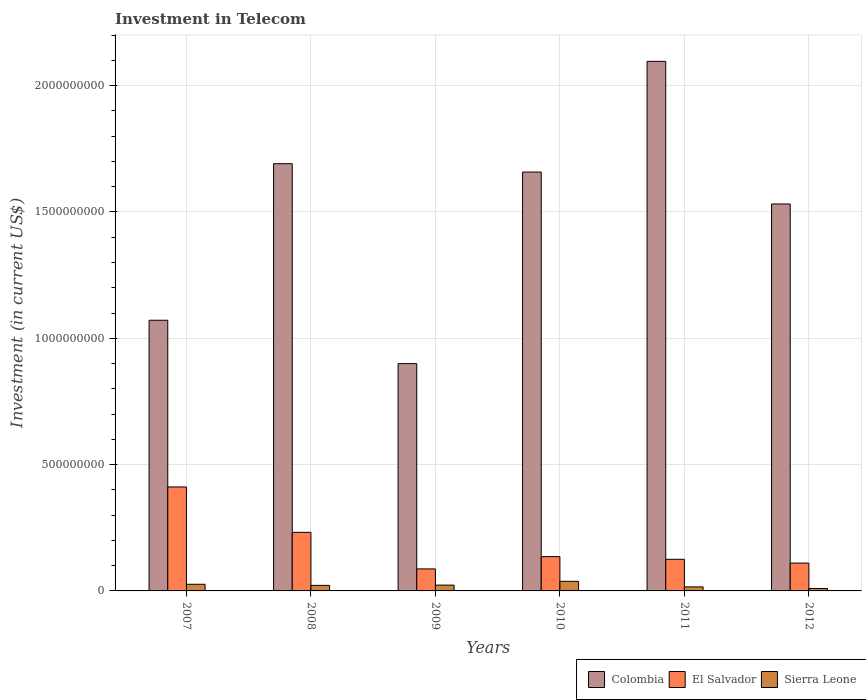How many different coloured bars are there?
Make the answer very short. 3. How many groups of bars are there?
Keep it short and to the point. 6. Are the number of bars per tick equal to the number of legend labels?
Provide a short and direct response. Yes. Are the number of bars on each tick of the X-axis equal?
Your response must be concise. Yes. How many bars are there on the 6th tick from the left?
Make the answer very short. 3. How many bars are there on the 3rd tick from the right?
Ensure brevity in your answer.  3. What is the amount invested in telecom in El Salvador in 2009?
Offer a very short reply. 8.71e+07. Across all years, what is the maximum amount invested in telecom in Sierra Leone?
Your response must be concise. 3.80e+07. Across all years, what is the minimum amount invested in telecom in El Salvador?
Offer a very short reply. 8.71e+07. In which year was the amount invested in telecom in Colombia minimum?
Give a very brief answer. 2009. What is the total amount invested in telecom in Colombia in the graph?
Provide a succinct answer. 8.95e+09. What is the difference between the amount invested in telecom in Sierra Leone in 2007 and that in 2010?
Give a very brief answer. -1.17e+07. What is the difference between the amount invested in telecom in El Salvador in 2009 and the amount invested in telecom in Colombia in 2012?
Give a very brief answer. -1.44e+09. What is the average amount invested in telecom in Colombia per year?
Ensure brevity in your answer.  1.49e+09. In the year 2007, what is the difference between the amount invested in telecom in Colombia and amount invested in telecom in Sierra Leone?
Your response must be concise. 1.05e+09. In how many years, is the amount invested in telecom in El Salvador greater than 200000000 US$?
Your answer should be compact. 2. What is the ratio of the amount invested in telecom in Sierra Leone in 2011 to that in 2012?
Keep it short and to the point. 1.64. Is the difference between the amount invested in telecom in Colombia in 2008 and 2012 greater than the difference between the amount invested in telecom in Sierra Leone in 2008 and 2012?
Your response must be concise. Yes. What is the difference between the highest and the second highest amount invested in telecom in Sierra Leone?
Your answer should be very brief. 1.17e+07. What is the difference between the highest and the lowest amount invested in telecom in Sierra Leone?
Your response must be concise. 2.83e+07. In how many years, is the amount invested in telecom in Sierra Leone greater than the average amount invested in telecom in Sierra Leone taken over all years?
Make the answer very short. 3. Is it the case that in every year, the sum of the amount invested in telecom in El Salvador and amount invested in telecom in Colombia is greater than the amount invested in telecom in Sierra Leone?
Ensure brevity in your answer.  Yes. Are all the bars in the graph horizontal?
Offer a very short reply. No. How many years are there in the graph?
Provide a succinct answer. 6. Are the values on the major ticks of Y-axis written in scientific E-notation?
Offer a very short reply. No. Where does the legend appear in the graph?
Keep it short and to the point. Bottom right. How many legend labels are there?
Provide a short and direct response. 3. What is the title of the graph?
Offer a very short reply. Investment in Telecom. What is the label or title of the Y-axis?
Provide a short and direct response. Investment (in current US$). What is the Investment (in current US$) of Colombia in 2007?
Provide a short and direct response. 1.07e+09. What is the Investment (in current US$) of El Salvador in 2007?
Give a very brief answer. 4.11e+08. What is the Investment (in current US$) in Sierra Leone in 2007?
Keep it short and to the point. 2.63e+07. What is the Investment (in current US$) in Colombia in 2008?
Provide a short and direct response. 1.69e+09. What is the Investment (in current US$) of El Salvador in 2008?
Your answer should be compact. 2.32e+08. What is the Investment (in current US$) in Sierra Leone in 2008?
Offer a terse response. 2.19e+07. What is the Investment (in current US$) in Colombia in 2009?
Provide a short and direct response. 9.00e+08. What is the Investment (in current US$) in El Salvador in 2009?
Your answer should be very brief. 8.71e+07. What is the Investment (in current US$) in Sierra Leone in 2009?
Your response must be concise. 2.30e+07. What is the Investment (in current US$) of Colombia in 2010?
Ensure brevity in your answer.  1.66e+09. What is the Investment (in current US$) in El Salvador in 2010?
Ensure brevity in your answer.  1.36e+08. What is the Investment (in current US$) in Sierra Leone in 2010?
Provide a short and direct response. 3.80e+07. What is the Investment (in current US$) of Colombia in 2011?
Ensure brevity in your answer.  2.10e+09. What is the Investment (in current US$) in El Salvador in 2011?
Your answer should be very brief. 1.25e+08. What is the Investment (in current US$) in Sierra Leone in 2011?
Offer a terse response. 1.59e+07. What is the Investment (in current US$) of Colombia in 2012?
Provide a short and direct response. 1.53e+09. What is the Investment (in current US$) in El Salvador in 2012?
Provide a succinct answer. 1.10e+08. What is the Investment (in current US$) in Sierra Leone in 2012?
Make the answer very short. 9.70e+06. Across all years, what is the maximum Investment (in current US$) of Colombia?
Ensure brevity in your answer.  2.10e+09. Across all years, what is the maximum Investment (in current US$) in El Salvador?
Your answer should be very brief. 4.11e+08. Across all years, what is the maximum Investment (in current US$) of Sierra Leone?
Provide a succinct answer. 3.80e+07. Across all years, what is the minimum Investment (in current US$) in Colombia?
Give a very brief answer. 9.00e+08. Across all years, what is the minimum Investment (in current US$) of El Salvador?
Offer a terse response. 8.71e+07. Across all years, what is the minimum Investment (in current US$) of Sierra Leone?
Offer a terse response. 9.70e+06. What is the total Investment (in current US$) of Colombia in the graph?
Provide a short and direct response. 8.95e+09. What is the total Investment (in current US$) of El Salvador in the graph?
Keep it short and to the point. 1.10e+09. What is the total Investment (in current US$) of Sierra Leone in the graph?
Your answer should be compact. 1.35e+08. What is the difference between the Investment (in current US$) in Colombia in 2007 and that in 2008?
Offer a very short reply. -6.20e+08. What is the difference between the Investment (in current US$) of El Salvador in 2007 and that in 2008?
Give a very brief answer. 1.80e+08. What is the difference between the Investment (in current US$) of Sierra Leone in 2007 and that in 2008?
Provide a succinct answer. 4.40e+06. What is the difference between the Investment (in current US$) in Colombia in 2007 and that in 2009?
Your answer should be compact. 1.72e+08. What is the difference between the Investment (in current US$) in El Salvador in 2007 and that in 2009?
Offer a very short reply. 3.24e+08. What is the difference between the Investment (in current US$) in Sierra Leone in 2007 and that in 2009?
Offer a very short reply. 3.30e+06. What is the difference between the Investment (in current US$) in Colombia in 2007 and that in 2010?
Ensure brevity in your answer.  -5.86e+08. What is the difference between the Investment (in current US$) of El Salvador in 2007 and that in 2010?
Ensure brevity in your answer.  2.76e+08. What is the difference between the Investment (in current US$) of Sierra Leone in 2007 and that in 2010?
Offer a terse response. -1.17e+07. What is the difference between the Investment (in current US$) of Colombia in 2007 and that in 2011?
Keep it short and to the point. -1.02e+09. What is the difference between the Investment (in current US$) in El Salvador in 2007 and that in 2011?
Your answer should be very brief. 2.86e+08. What is the difference between the Investment (in current US$) of Sierra Leone in 2007 and that in 2011?
Ensure brevity in your answer.  1.04e+07. What is the difference between the Investment (in current US$) of Colombia in 2007 and that in 2012?
Give a very brief answer. -4.60e+08. What is the difference between the Investment (in current US$) in El Salvador in 2007 and that in 2012?
Provide a short and direct response. 3.01e+08. What is the difference between the Investment (in current US$) in Sierra Leone in 2007 and that in 2012?
Provide a succinct answer. 1.66e+07. What is the difference between the Investment (in current US$) in Colombia in 2008 and that in 2009?
Offer a terse response. 7.91e+08. What is the difference between the Investment (in current US$) of El Salvador in 2008 and that in 2009?
Give a very brief answer. 1.45e+08. What is the difference between the Investment (in current US$) in Sierra Leone in 2008 and that in 2009?
Your answer should be compact. -1.10e+06. What is the difference between the Investment (in current US$) of Colombia in 2008 and that in 2010?
Your answer should be very brief. 3.31e+07. What is the difference between the Investment (in current US$) in El Salvador in 2008 and that in 2010?
Keep it short and to the point. 9.61e+07. What is the difference between the Investment (in current US$) of Sierra Leone in 2008 and that in 2010?
Ensure brevity in your answer.  -1.61e+07. What is the difference between the Investment (in current US$) in Colombia in 2008 and that in 2011?
Offer a terse response. -4.05e+08. What is the difference between the Investment (in current US$) of El Salvador in 2008 and that in 2011?
Offer a terse response. 1.07e+08. What is the difference between the Investment (in current US$) in Sierra Leone in 2008 and that in 2011?
Your response must be concise. 6.00e+06. What is the difference between the Investment (in current US$) in Colombia in 2008 and that in 2012?
Provide a short and direct response. 1.59e+08. What is the difference between the Investment (in current US$) in El Salvador in 2008 and that in 2012?
Your answer should be very brief. 1.22e+08. What is the difference between the Investment (in current US$) in Sierra Leone in 2008 and that in 2012?
Your response must be concise. 1.22e+07. What is the difference between the Investment (in current US$) in Colombia in 2009 and that in 2010?
Offer a terse response. -7.58e+08. What is the difference between the Investment (in current US$) in El Salvador in 2009 and that in 2010?
Offer a very short reply. -4.86e+07. What is the difference between the Investment (in current US$) in Sierra Leone in 2009 and that in 2010?
Your answer should be compact. -1.50e+07. What is the difference between the Investment (in current US$) in Colombia in 2009 and that in 2011?
Give a very brief answer. -1.20e+09. What is the difference between the Investment (in current US$) in El Salvador in 2009 and that in 2011?
Provide a short and direct response. -3.81e+07. What is the difference between the Investment (in current US$) of Sierra Leone in 2009 and that in 2011?
Your answer should be compact. 7.10e+06. What is the difference between the Investment (in current US$) of Colombia in 2009 and that in 2012?
Provide a short and direct response. -6.32e+08. What is the difference between the Investment (in current US$) of El Salvador in 2009 and that in 2012?
Your answer should be very brief. -2.31e+07. What is the difference between the Investment (in current US$) in Sierra Leone in 2009 and that in 2012?
Make the answer very short. 1.33e+07. What is the difference between the Investment (in current US$) in Colombia in 2010 and that in 2011?
Offer a terse response. -4.38e+08. What is the difference between the Investment (in current US$) in El Salvador in 2010 and that in 2011?
Your answer should be very brief. 1.05e+07. What is the difference between the Investment (in current US$) of Sierra Leone in 2010 and that in 2011?
Make the answer very short. 2.21e+07. What is the difference between the Investment (in current US$) of Colombia in 2010 and that in 2012?
Offer a terse response. 1.26e+08. What is the difference between the Investment (in current US$) in El Salvador in 2010 and that in 2012?
Offer a very short reply. 2.55e+07. What is the difference between the Investment (in current US$) of Sierra Leone in 2010 and that in 2012?
Make the answer very short. 2.83e+07. What is the difference between the Investment (in current US$) of Colombia in 2011 and that in 2012?
Your response must be concise. 5.64e+08. What is the difference between the Investment (in current US$) in El Salvador in 2011 and that in 2012?
Your response must be concise. 1.50e+07. What is the difference between the Investment (in current US$) in Sierra Leone in 2011 and that in 2012?
Provide a short and direct response. 6.20e+06. What is the difference between the Investment (in current US$) of Colombia in 2007 and the Investment (in current US$) of El Salvador in 2008?
Your answer should be very brief. 8.40e+08. What is the difference between the Investment (in current US$) of Colombia in 2007 and the Investment (in current US$) of Sierra Leone in 2008?
Make the answer very short. 1.05e+09. What is the difference between the Investment (in current US$) in El Salvador in 2007 and the Investment (in current US$) in Sierra Leone in 2008?
Offer a terse response. 3.90e+08. What is the difference between the Investment (in current US$) in Colombia in 2007 and the Investment (in current US$) in El Salvador in 2009?
Give a very brief answer. 9.84e+08. What is the difference between the Investment (in current US$) in Colombia in 2007 and the Investment (in current US$) in Sierra Leone in 2009?
Offer a terse response. 1.05e+09. What is the difference between the Investment (in current US$) of El Salvador in 2007 and the Investment (in current US$) of Sierra Leone in 2009?
Offer a very short reply. 3.88e+08. What is the difference between the Investment (in current US$) of Colombia in 2007 and the Investment (in current US$) of El Salvador in 2010?
Provide a succinct answer. 9.36e+08. What is the difference between the Investment (in current US$) in Colombia in 2007 and the Investment (in current US$) in Sierra Leone in 2010?
Your response must be concise. 1.03e+09. What is the difference between the Investment (in current US$) in El Salvador in 2007 and the Investment (in current US$) in Sierra Leone in 2010?
Offer a very short reply. 3.73e+08. What is the difference between the Investment (in current US$) in Colombia in 2007 and the Investment (in current US$) in El Salvador in 2011?
Provide a short and direct response. 9.46e+08. What is the difference between the Investment (in current US$) in Colombia in 2007 and the Investment (in current US$) in Sierra Leone in 2011?
Ensure brevity in your answer.  1.06e+09. What is the difference between the Investment (in current US$) in El Salvador in 2007 and the Investment (in current US$) in Sierra Leone in 2011?
Give a very brief answer. 3.96e+08. What is the difference between the Investment (in current US$) in Colombia in 2007 and the Investment (in current US$) in El Salvador in 2012?
Ensure brevity in your answer.  9.61e+08. What is the difference between the Investment (in current US$) in Colombia in 2007 and the Investment (in current US$) in Sierra Leone in 2012?
Offer a very short reply. 1.06e+09. What is the difference between the Investment (in current US$) in El Salvador in 2007 and the Investment (in current US$) in Sierra Leone in 2012?
Your answer should be compact. 4.02e+08. What is the difference between the Investment (in current US$) of Colombia in 2008 and the Investment (in current US$) of El Salvador in 2009?
Make the answer very short. 1.60e+09. What is the difference between the Investment (in current US$) of Colombia in 2008 and the Investment (in current US$) of Sierra Leone in 2009?
Keep it short and to the point. 1.67e+09. What is the difference between the Investment (in current US$) in El Salvador in 2008 and the Investment (in current US$) in Sierra Leone in 2009?
Provide a succinct answer. 2.09e+08. What is the difference between the Investment (in current US$) of Colombia in 2008 and the Investment (in current US$) of El Salvador in 2010?
Offer a terse response. 1.56e+09. What is the difference between the Investment (in current US$) of Colombia in 2008 and the Investment (in current US$) of Sierra Leone in 2010?
Make the answer very short. 1.65e+09. What is the difference between the Investment (in current US$) of El Salvador in 2008 and the Investment (in current US$) of Sierra Leone in 2010?
Your answer should be very brief. 1.94e+08. What is the difference between the Investment (in current US$) of Colombia in 2008 and the Investment (in current US$) of El Salvador in 2011?
Offer a very short reply. 1.57e+09. What is the difference between the Investment (in current US$) of Colombia in 2008 and the Investment (in current US$) of Sierra Leone in 2011?
Provide a succinct answer. 1.68e+09. What is the difference between the Investment (in current US$) of El Salvador in 2008 and the Investment (in current US$) of Sierra Leone in 2011?
Your response must be concise. 2.16e+08. What is the difference between the Investment (in current US$) of Colombia in 2008 and the Investment (in current US$) of El Salvador in 2012?
Provide a short and direct response. 1.58e+09. What is the difference between the Investment (in current US$) in Colombia in 2008 and the Investment (in current US$) in Sierra Leone in 2012?
Your answer should be very brief. 1.68e+09. What is the difference between the Investment (in current US$) in El Salvador in 2008 and the Investment (in current US$) in Sierra Leone in 2012?
Offer a very short reply. 2.22e+08. What is the difference between the Investment (in current US$) in Colombia in 2009 and the Investment (in current US$) in El Salvador in 2010?
Ensure brevity in your answer.  7.64e+08. What is the difference between the Investment (in current US$) in Colombia in 2009 and the Investment (in current US$) in Sierra Leone in 2010?
Offer a very short reply. 8.62e+08. What is the difference between the Investment (in current US$) in El Salvador in 2009 and the Investment (in current US$) in Sierra Leone in 2010?
Offer a terse response. 4.91e+07. What is the difference between the Investment (in current US$) in Colombia in 2009 and the Investment (in current US$) in El Salvador in 2011?
Provide a short and direct response. 7.74e+08. What is the difference between the Investment (in current US$) in Colombia in 2009 and the Investment (in current US$) in Sierra Leone in 2011?
Give a very brief answer. 8.84e+08. What is the difference between the Investment (in current US$) of El Salvador in 2009 and the Investment (in current US$) of Sierra Leone in 2011?
Your response must be concise. 7.12e+07. What is the difference between the Investment (in current US$) in Colombia in 2009 and the Investment (in current US$) in El Salvador in 2012?
Your response must be concise. 7.90e+08. What is the difference between the Investment (in current US$) of Colombia in 2009 and the Investment (in current US$) of Sierra Leone in 2012?
Provide a short and direct response. 8.90e+08. What is the difference between the Investment (in current US$) of El Salvador in 2009 and the Investment (in current US$) of Sierra Leone in 2012?
Offer a terse response. 7.74e+07. What is the difference between the Investment (in current US$) in Colombia in 2010 and the Investment (in current US$) in El Salvador in 2011?
Your response must be concise. 1.53e+09. What is the difference between the Investment (in current US$) in Colombia in 2010 and the Investment (in current US$) in Sierra Leone in 2011?
Your response must be concise. 1.64e+09. What is the difference between the Investment (in current US$) in El Salvador in 2010 and the Investment (in current US$) in Sierra Leone in 2011?
Give a very brief answer. 1.20e+08. What is the difference between the Investment (in current US$) of Colombia in 2010 and the Investment (in current US$) of El Salvador in 2012?
Offer a very short reply. 1.55e+09. What is the difference between the Investment (in current US$) in Colombia in 2010 and the Investment (in current US$) in Sierra Leone in 2012?
Provide a succinct answer. 1.65e+09. What is the difference between the Investment (in current US$) of El Salvador in 2010 and the Investment (in current US$) of Sierra Leone in 2012?
Make the answer very short. 1.26e+08. What is the difference between the Investment (in current US$) of Colombia in 2011 and the Investment (in current US$) of El Salvador in 2012?
Offer a terse response. 1.99e+09. What is the difference between the Investment (in current US$) of Colombia in 2011 and the Investment (in current US$) of Sierra Leone in 2012?
Make the answer very short. 2.09e+09. What is the difference between the Investment (in current US$) of El Salvador in 2011 and the Investment (in current US$) of Sierra Leone in 2012?
Your response must be concise. 1.16e+08. What is the average Investment (in current US$) of Colombia per year?
Offer a very short reply. 1.49e+09. What is the average Investment (in current US$) in El Salvador per year?
Keep it short and to the point. 1.84e+08. What is the average Investment (in current US$) in Sierra Leone per year?
Make the answer very short. 2.25e+07. In the year 2007, what is the difference between the Investment (in current US$) in Colombia and Investment (in current US$) in El Salvador?
Offer a very short reply. 6.60e+08. In the year 2007, what is the difference between the Investment (in current US$) in Colombia and Investment (in current US$) in Sierra Leone?
Your answer should be very brief. 1.05e+09. In the year 2007, what is the difference between the Investment (in current US$) in El Salvador and Investment (in current US$) in Sierra Leone?
Give a very brief answer. 3.85e+08. In the year 2008, what is the difference between the Investment (in current US$) in Colombia and Investment (in current US$) in El Salvador?
Your answer should be very brief. 1.46e+09. In the year 2008, what is the difference between the Investment (in current US$) of Colombia and Investment (in current US$) of Sierra Leone?
Keep it short and to the point. 1.67e+09. In the year 2008, what is the difference between the Investment (in current US$) in El Salvador and Investment (in current US$) in Sierra Leone?
Your response must be concise. 2.10e+08. In the year 2009, what is the difference between the Investment (in current US$) in Colombia and Investment (in current US$) in El Salvador?
Offer a terse response. 8.13e+08. In the year 2009, what is the difference between the Investment (in current US$) in Colombia and Investment (in current US$) in Sierra Leone?
Keep it short and to the point. 8.77e+08. In the year 2009, what is the difference between the Investment (in current US$) in El Salvador and Investment (in current US$) in Sierra Leone?
Give a very brief answer. 6.41e+07. In the year 2010, what is the difference between the Investment (in current US$) of Colombia and Investment (in current US$) of El Salvador?
Keep it short and to the point. 1.52e+09. In the year 2010, what is the difference between the Investment (in current US$) in Colombia and Investment (in current US$) in Sierra Leone?
Your response must be concise. 1.62e+09. In the year 2010, what is the difference between the Investment (in current US$) in El Salvador and Investment (in current US$) in Sierra Leone?
Your answer should be compact. 9.77e+07. In the year 2011, what is the difference between the Investment (in current US$) of Colombia and Investment (in current US$) of El Salvador?
Keep it short and to the point. 1.97e+09. In the year 2011, what is the difference between the Investment (in current US$) of Colombia and Investment (in current US$) of Sierra Leone?
Keep it short and to the point. 2.08e+09. In the year 2011, what is the difference between the Investment (in current US$) of El Salvador and Investment (in current US$) of Sierra Leone?
Offer a very short reply. 1.09e+08. In the year 2012, what is the difference between the Investment (in current US$) in Colombia and Investment (in current US$) in El Salvador?
Your answer should be compact. 1.42e+09. In the year 2012, what is the difference between the Investment (in current US$) of Colombia and Investment (in current US$) of Sierra Leone?
Keep it short and to the point. 1.52e+09. In the year 2012, what is the difference between the Investment (in current US$) of El Salvador and Investment (in current US$) of Sierra Leone?
Your response must be concise. 1.00e+08. What is the ratio of the Investment (in current US$) in Colombia in 2007 to that in 2008?
Your response must be concise. 0.63. What is the ratio of the Investment (in current US$) of El Salvador in 2007 to that in 2008?
Make the answer very short. 1.78. What is the ratio of the Investment (in current US$) of Sierra Leone in 2007 to that in 2008?
Give a very brief answer. 1.2. What is the ratio of the Investment (in current US$) of Colombia in 2007 to that in 2009?
Offer a very short reply. 1.19. What is the ratio of the Investment (in current US$) of El Salvador in 2007 to that in 2009?
Provide a short and direct response. 4.72. What is the ratio of the Investment (in current US$) in Sierra Leone in 2007 to that in 2009?
Provide a short and direct response. 1.14. What is the ratio of the Investment (in current US$) of Colombia in 2007 to that in 2010?
Provide a short and direct response. 0.65. What is the ratio of the Investment (in current US$) of El Salvador in 2007 to that in 2010?
Give a very brief answer. 3.03. What is the ratio of the Investment (in current US$) in Sierra Leone in 2007 to that in 2010?
Offer a terse response. 0.69. What is the ratio of the Investment (in current US$) of Colombia in 2007 to that in 2011?
Keep it short and to the point. 0.51. What is the ratio of the Investment (in current US$) of El Salvador in 2007 to that in 2011?
Your response must be concise. 3.29. What is the ratio of the Investment (in current US$) in Sierra Leone in 2007 to that in 2011?
Provide a short and direct response. 1.65. What is the ratio of the Investment (in current US$) in Colombia in 2007 to that in 2012?
Your response must be concise. 0.7. What is the ratio of the Investment (in current US$) of El Salvador in 2007 to that in 2012?
Make the answer very short. 3.73. What is the ratio of the Investment (in current US$) of Sierra Leone in 2007 to that in 2012?
Make the answer very short. 2.71. What is the ratio of the Investment (in current US$) of Colombia in 2008 to that in 2009?
Keep it short and to the point. 1.88. What is the ratio of the Investment (in current US$) in El Salvador in 2008 to that in 2009?
Provide a succinct answer. 2.66. What is the ratio of the Investment (in current US$) of Sierra Leone in 2008 to that in 2009?
Keep it short and to the point. 0.95. What is the ratio of the Investment (in current US$) of El Salvador in 2008 to that in 2010?
Give a very brief answer. 1.71. What is the ratio of the Investment (in current US$) in Sierra Leone in 2008 to that in 2010?
Make the answer very short. 0.58. What is the ratio of the Investment (in current US$) in Colombia in 2008 to that in 2011?
Provide a succinct answer. 0.81. What is the ratio of the Investment (in current US$) of El Salvador in 2008 to that in 2011?
Provide a succinct answer. 1.85. What is the ratio of the Investment (in current US$) of Sierra Leone in 2008 to that in 2011?
Your response must be concise. 1.38. What is the ratio of the Investment (in current US$) of Colombia in 2008 to that in 2012?
Your answer should be compact. 1.1. What is the ratio of the Investment (in current US$) of El Salvador in 2008 to that in 2012?
Give a very brief answer. 2.1. What is the ratio of the Investment (in current US$) in Sierra Leone in 2008 to that in 2012?
Provide a succinct answer. 2.26. What is the ratio of the Investment (in current US$) of Colombia in 2009 to that in 2010?
Your answer should be very brief. 0.54. What is the ratio of the Investment (in current US$) of El Salvador in 2009 to that in 2010?
Provide a succinct answer. 0.64. What is the ratio of the Investment (in current US$) of Sierra Leone in 2009 to that in 2010?
Your answer should be very brief. 0.61. What is the ratio of the Investment (in current US$) in Colombia in 2009 to that in 2011?
Provide a short and direct response. 0.43. What is the ratio of the Investment (in current US$) in El Salvador in 2009 to that in 2011?
Keep it short and to the point. 0.7. What is the ratio of the Investment (in current US$) in Sierra Leone in 2009 to that in 2011?
Your response must be concise. 1.45. What is the ratio of the Investment (in current US$) of Colombia in 2009 to that in 2012?
Ensure brevity in your answer.  0.59. What is the ratio of the Investment (in current US$) of El Salvador in 2009 to that in 2012?
Provide a short and direct response. 0.79. What is the ratio of the Investment (in current US$) in Sierra Leone in 2009 to that in 2012?
Offer a very short reply. 2.37. What is the ratio of the Investment (in current US$) in Colombia in 2010 to that in 2011?
Provide a succinct answer. 0.79. What is the ratio of the Investment (in current US$) in El Salvador in 2010 to that in 2011?
Your response must be concise. 1.08. What is the ratio of the Investment (in current US$) in Sierra Leone in 2010 to that in 2011?
Keep it short and to the point. 2.39. What is the ratio of the Investment (in current US$) of Colombia in 2010 to that in 2012?
Your answer should be compact. 1.08. What is the ratio of the Investment (in current US$) in El Salvador in 2010 to that in 2012?
Keep it short and to the point. 1.23. What is the ratio of the Investment (in current US$) of Sierra Leone in 2010 to that in 2012?
Keep it short and to the point. 3.92. What is the ratio of the Investment (in current US$) of Colombia in 2011 to that in 2012?
Keep it short and to the point. 1.37. What is the ratio of the Investment (in current US$) in El Salvador in 2011 to that in 2012?
Provide a short and direct response. 1.14. What is the ratio of the Investment (in current US$) in Sierra Leone in 2011 to that in 2012?
Ensure brevity in your answer.  1.64. What is the difference between the highest and the second highest Investment (in current US$) of Colombia?
Keep it short and to the point. 4.05e+08. What is the difference between the highest and the second highest Investment (in current US$) of El Salvador?
Offer a terse response. 1.80e+08. What is the difference between the highest and the second highest Investment (in current US$) of Sierra Leone?
Offer a terse response. 1.17e+07. What is the difference between the highest and the lowest Investment (in current US$) of Colombia?
Offer a very short reply. 1.20e+09. What is the difference between the highest and the lowest Investment (in current US$) of El Salvador?
Your response must be concise. 3.24e+08. What is the difference between the highest and the lowest Investment (in current US$) in Sierra Leone?
Keep it short and to the point. 2.83e+07. 